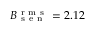<formula> <loc_0><loc_0><loc_500><loc_500>B _ { s e n } ^ { r m s } = 2 . 1 2</formula> 